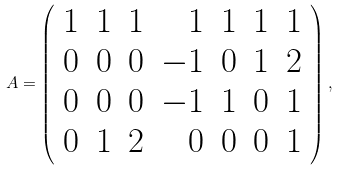<formula> <loc_0><loc_0><loc_500><loc_500>A = \left ( \begin{array} { c c c r c c c } 1 & 1 & 1 & 1 & 1 & 1 & 1 \\ 0 & 0 & 0 & - 1 & 0 & 1 & 2 \\ 0 & 0 & 0 & - 1 & 1 & 0 & 1 \\ 0 & 1 & 2 & 0 & 0 & 0 & 1 \end{array} \right ) ,</formula> 